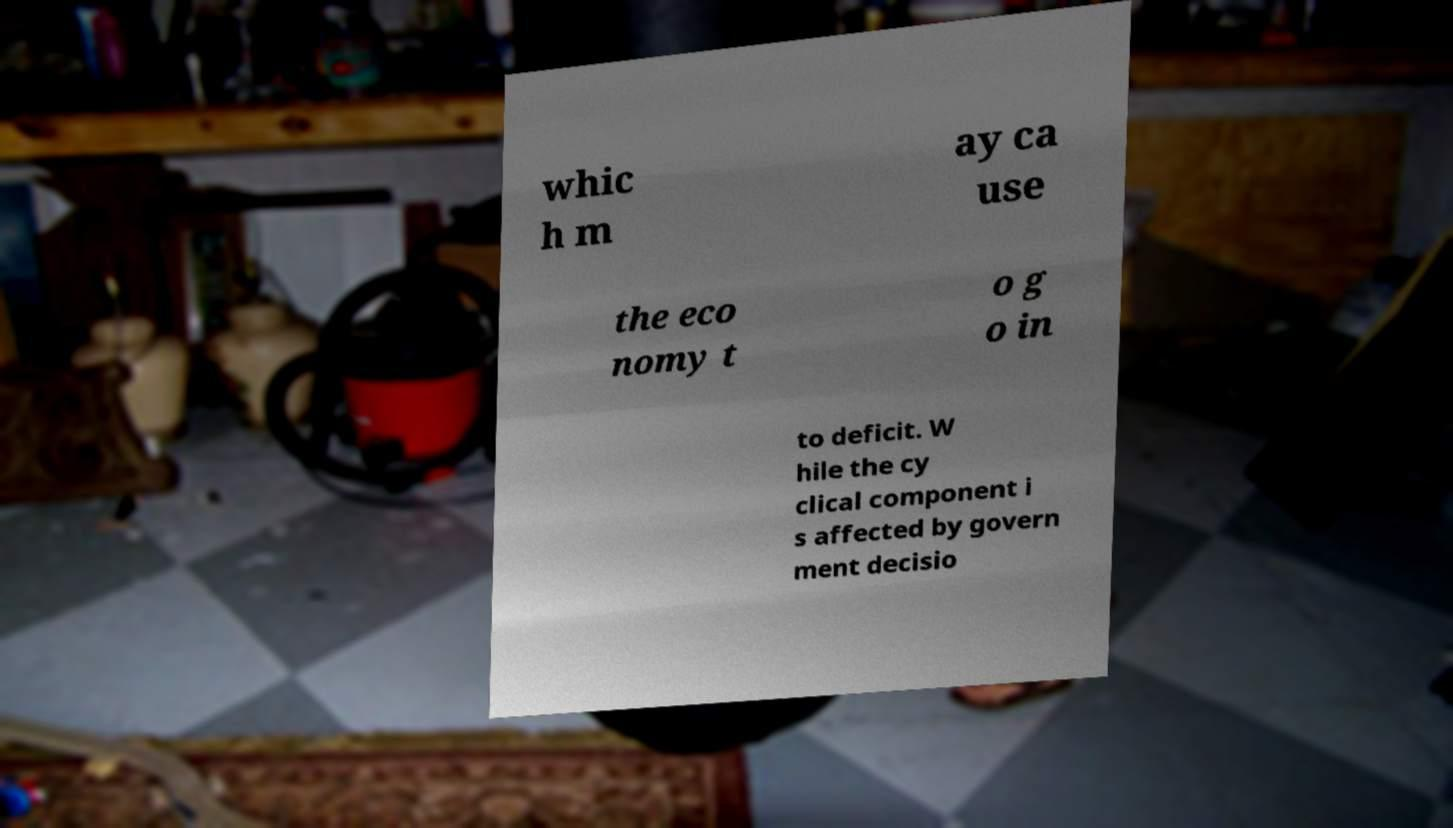Please read and relay the text visible in this image. What does it say? whic h m ay ca use the eco nomy t o g o in to deficit. W hile the cy clical component i s affected by govern ment decisio 